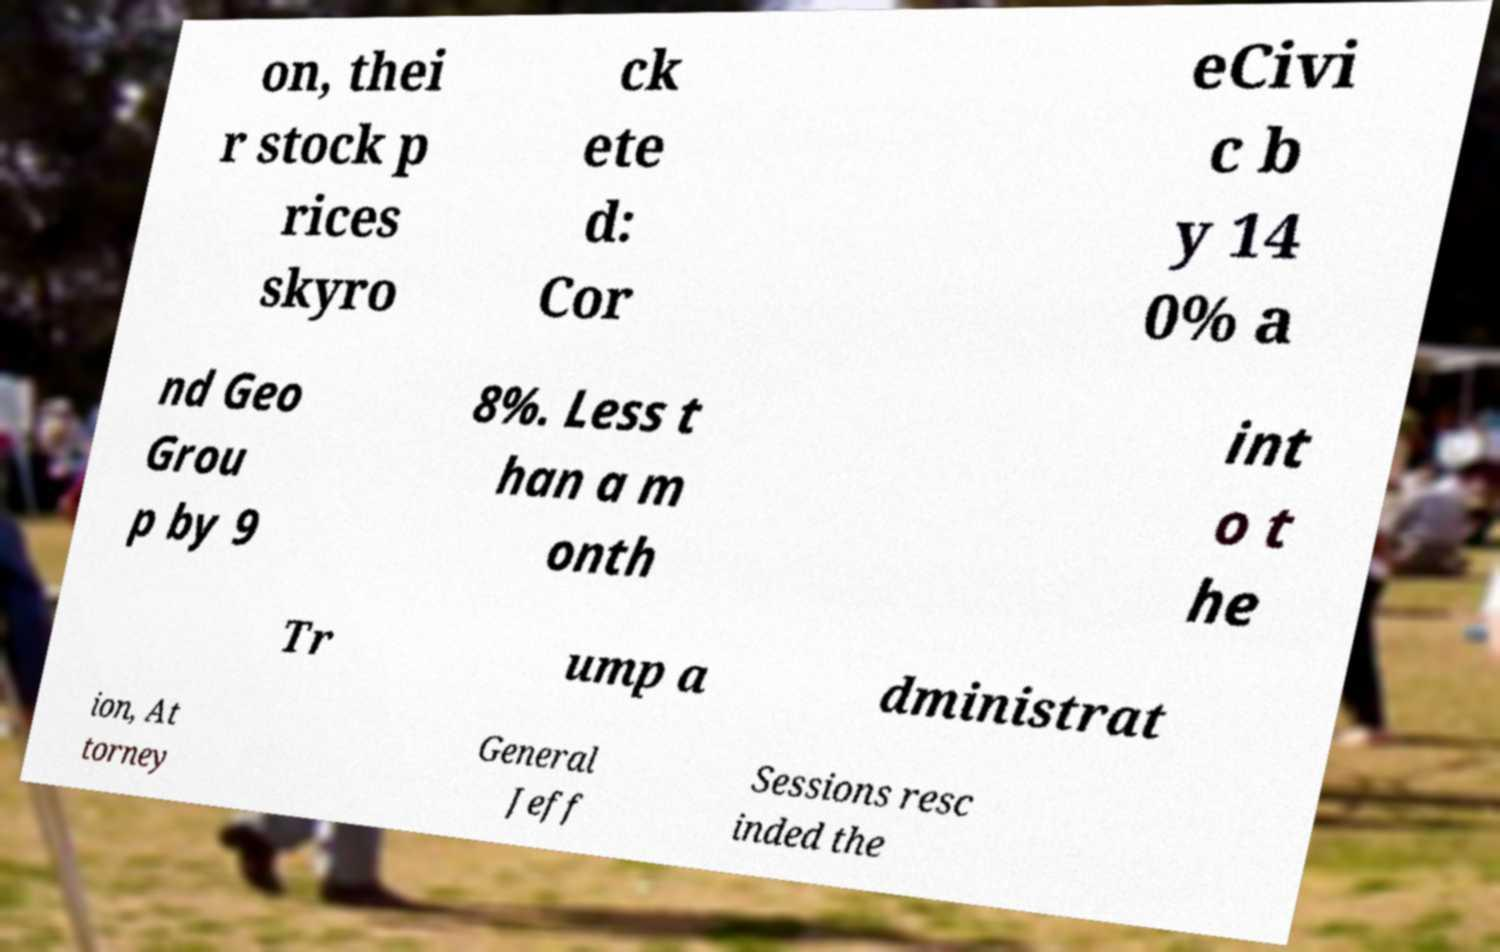Can you read and provide the text displayed in the image?This photo seems to have some interesting text. Can you extract and type it out for me? on, thei r stock p rices skyro ck ete d: Cor eCivi c b y 14 0% a nd Geo Grou p by 9 8%. Less t han a m onth int o t he Tr ump a dministrat ion, At torney General Jeff Sessions resc inded the 